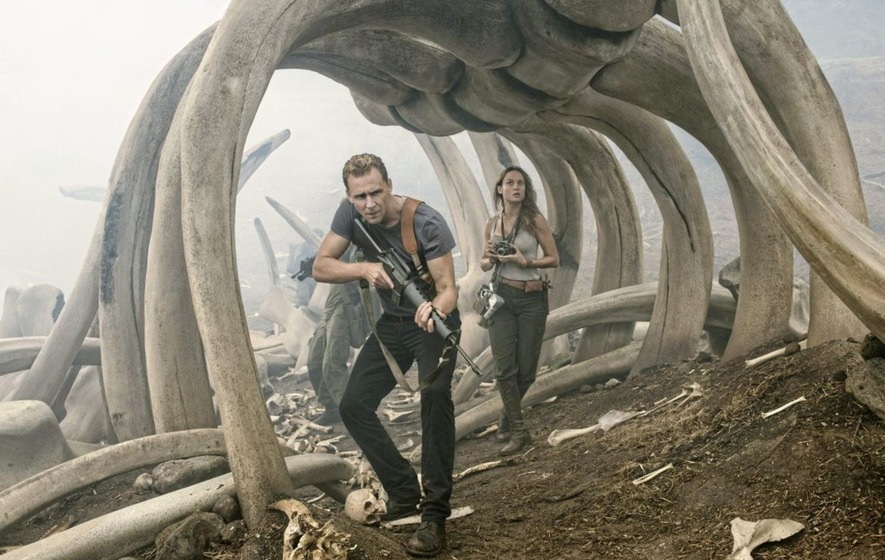What kind of environment do you think the characters are in? The characters appear to be in a prehistoric or forgotten land, as evidenced by the massive bones and the desolate, foggy landscape. The scene evokes a sense of ancient danger, giving the impression that they are exploring the ruins of a world dominated by enormous, possibly extinct creatures. 